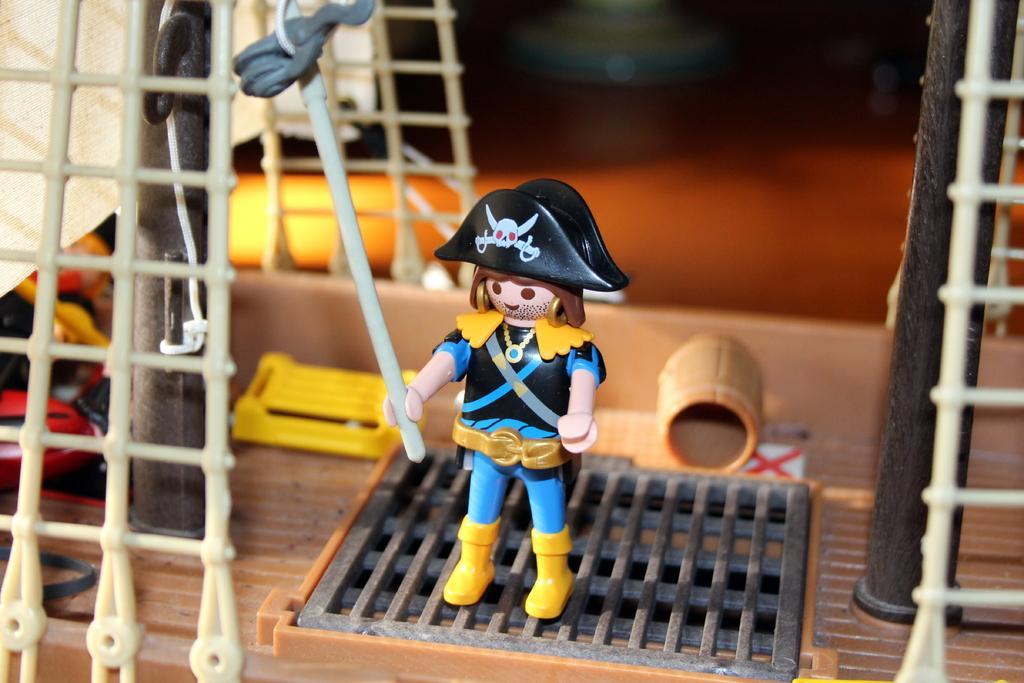Could you give a brief overview of what you see in this image? In this image, we can see toys and the background of the image is blurred. 